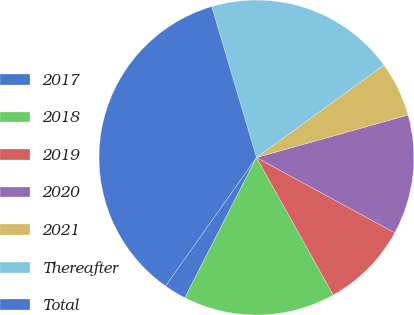<chart> <loc_0><loc_0><loc_500><loc_500><pie_chart><fcel>2017<fcel>2018<fcel>2019<fcel>2020<fcel>2021<fcel>Thereafter<fcel>Total<nl><fcel>2.29%<fcel>15.62%<fcel>8.96%<fcel>12.29%<fcel>5.63%<fcel>19.6%<fcel>35.61%<nl></chart> 